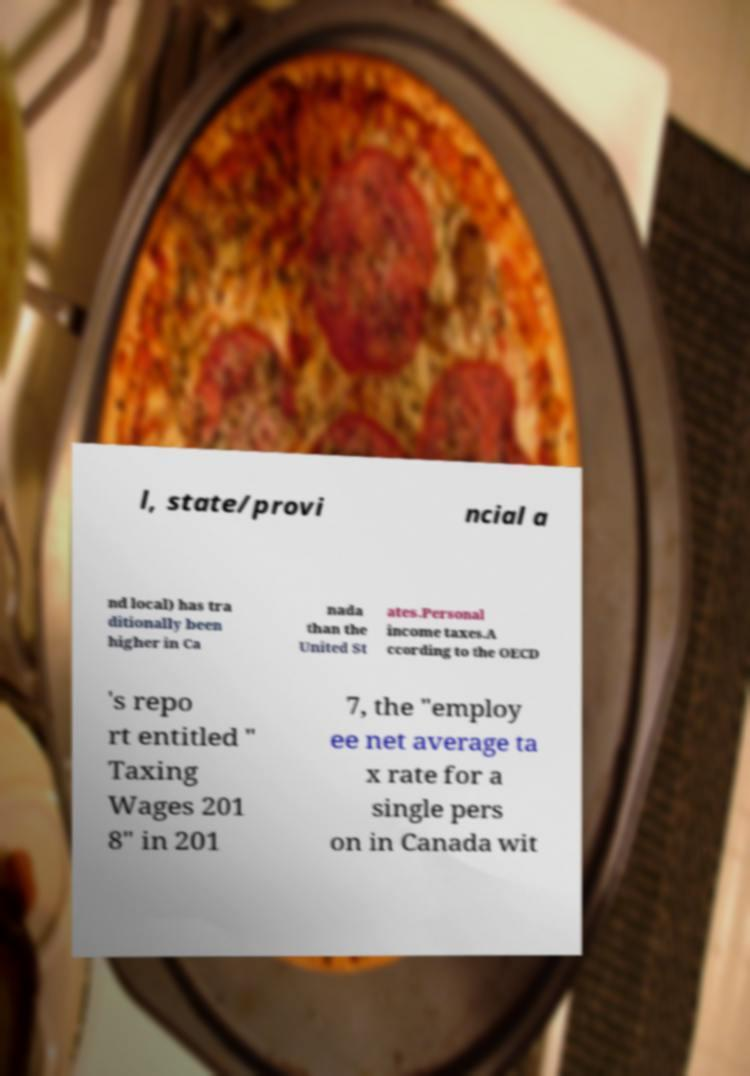I need the written content from this picture converted into text. Can you do that? l, state/provi ncial a nd local) has tra ditionally been higher in Ca nada than the United St ates.Personal income taxes.A ccording to the OECD 's repo rt entitled " Taxing Wages 201 8" in 201 7, the "employ ee net average ta x rate for a single pers on in Canada wit 